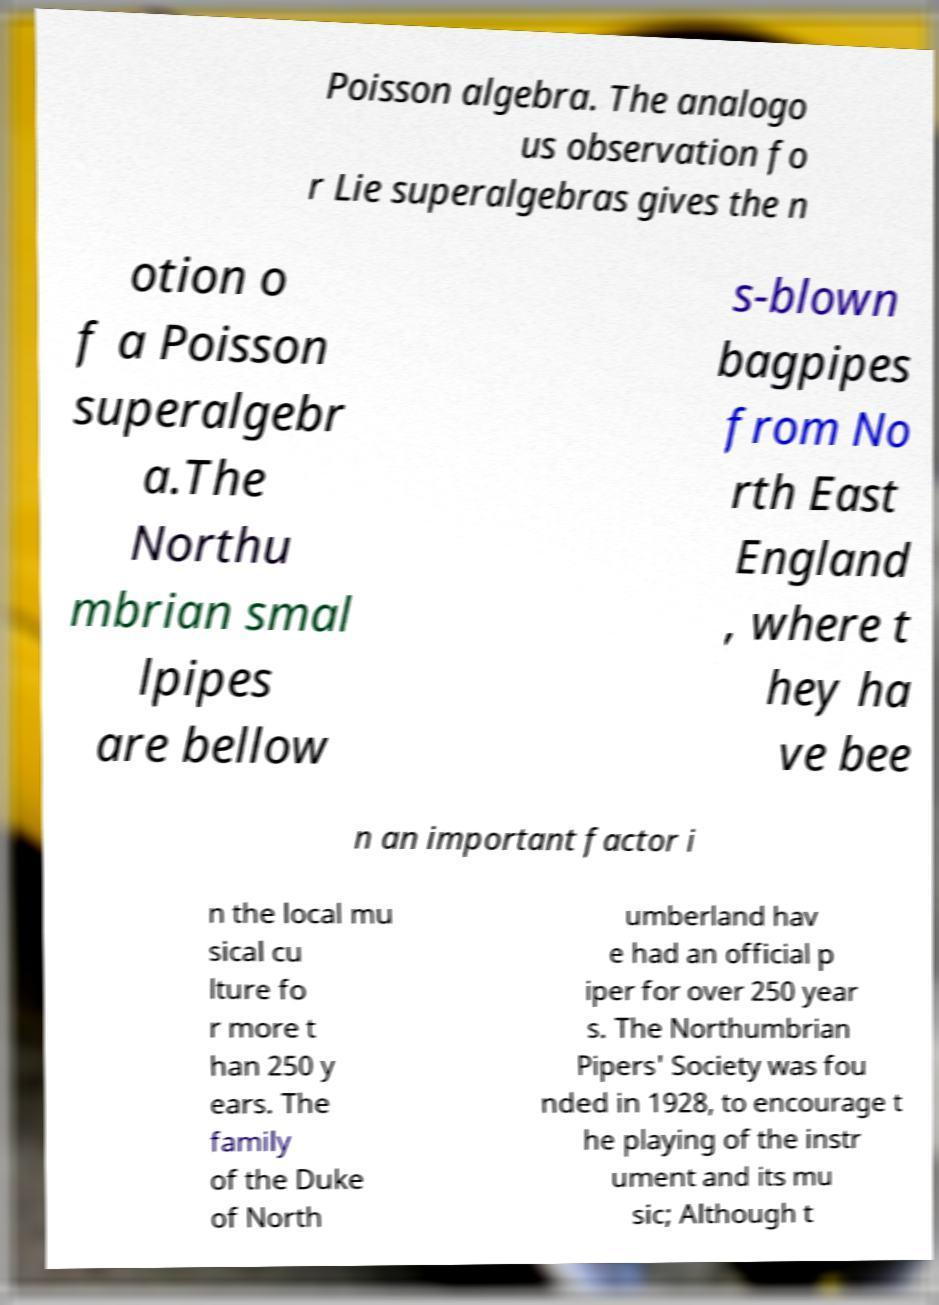Please identify and transcribe the text found in this image. Poisson algebra. The analogo us observation fo r Lie superalgebras gives the n otion o f a Poisson superalgebr a.The Northu mbrian smal lpipes are bellow s-blown bagpipes from No rth East England , where t hey ha ve bee n an important factor i n the local mu sical cu lture fo r more t han 250 y ears. The family of the Duke of North umberland hav e had an official p iper for over 250 year s. The Northumbrian Pipers' Society was fou nded in 1928, to encourage t he playing of the instr ument and its mu sic; Although t 